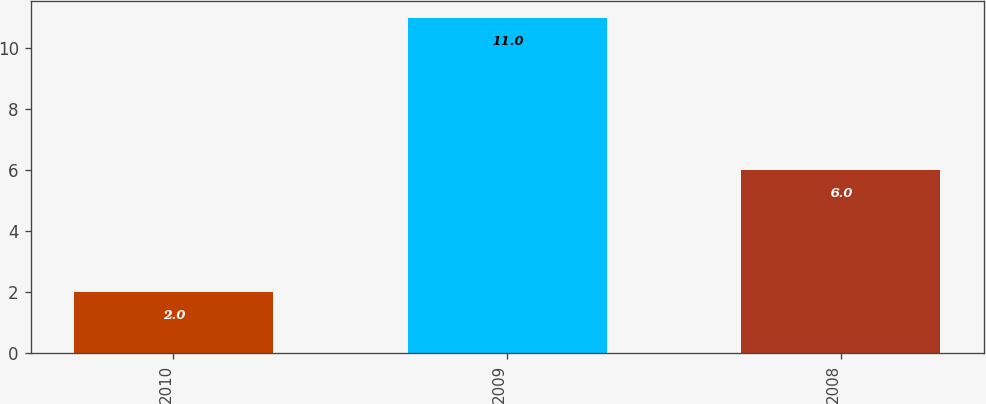Convert chart. <chart><loc_0><loc_0><loc_500><loc_500><bar_chart><fcel>2010<fcel>2009<fcel>2008<nl><fcel>2<fcel>11<fcel>6<nl></chart> 